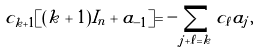Convert formula to latex. <formula><loc_0><loc_0><loc_500><loc_500>c _ { k + 1 } [ ( k + 1 ) I _ { n } + a _ { - 1 } ] = - \sum _ { j + \ell = k } c _ { \ell } a _ { j } ,</formula> 